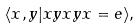<formula> <loc_0><loc_0><loc_500><loc_500>\langle x , y | x y x y x = e \rangle ,</formula> 